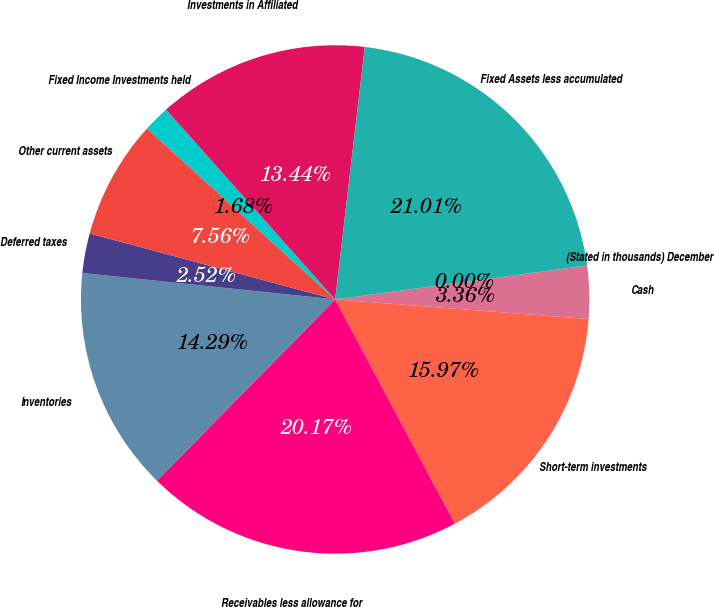<chart> <loc_0><loc_0><loc_500><loc_500><pie_chart><fcel>(Stated in thousands) December<fcel>Cash<fcel>Short-term investments<fcel>Receivables less allowance for<fcel>Inventories<fcel>Deferred taxes<fcel>Other current assets<fcel>Fixed Income Investments held<fcel>Investments in Affiliated<fcel>Fixed Assets less accumulated<nl><fcel>0.0%<fcel>3.36%<fcel>15.97%<fcel>20.17%<fcel>14.29%<fcel>2.52%<fcel>7.56%<fcel>1.68%<fcel>13.44%<fcel>21.01%<nl></chart> 